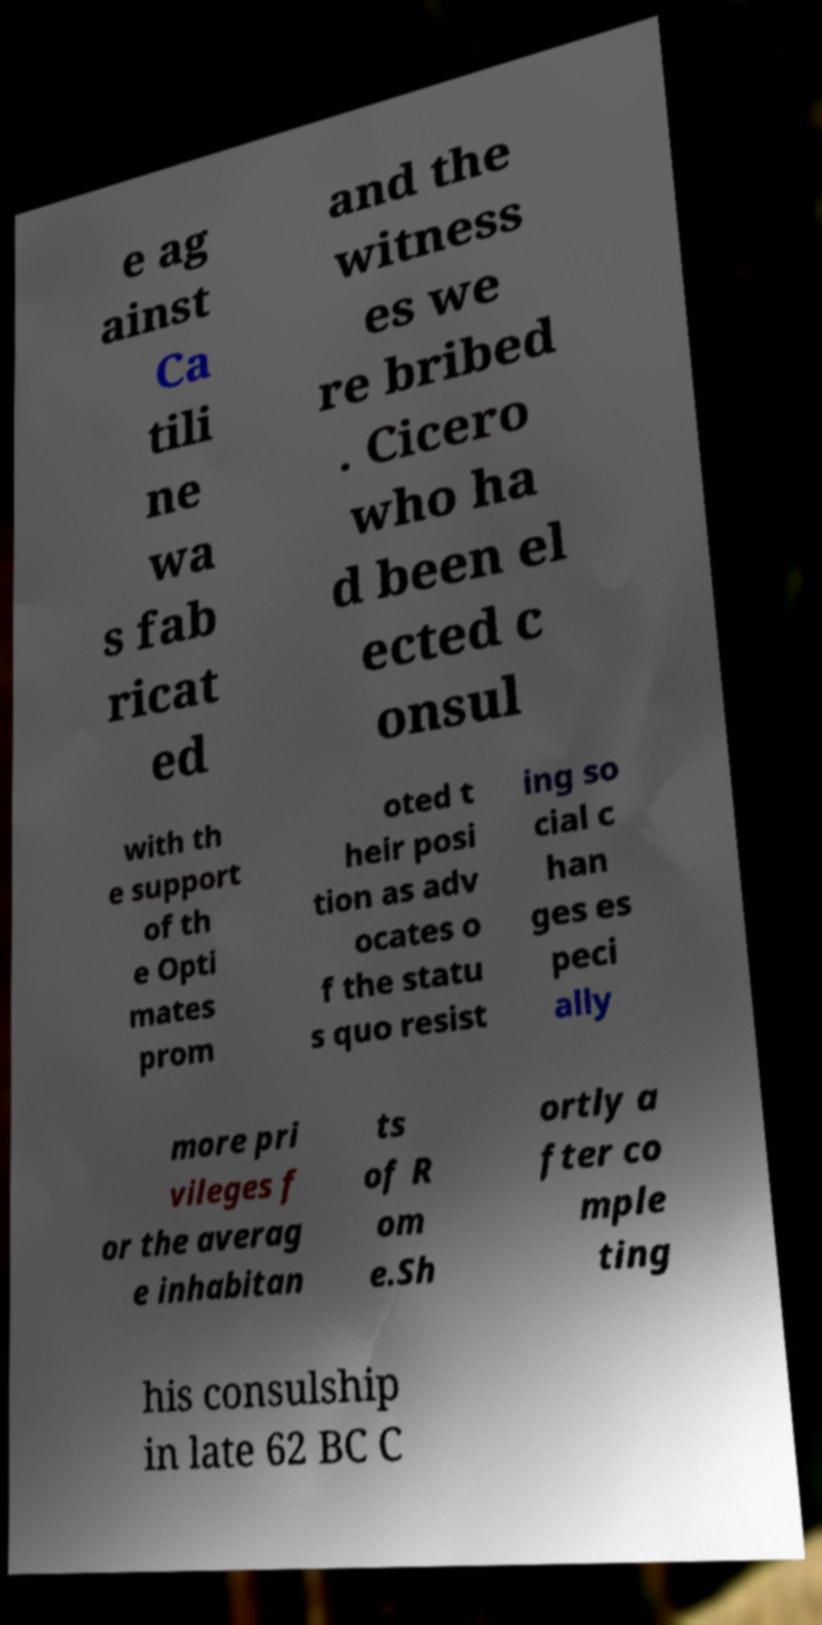Could you assist in decoding the text presented in this image and type it out clearly? e ag ainst Ca tili ne wa s fab ricat ed and the witness es we re bribed . Cicero who ha d been el ected c onsul with th e support of th e Opti mates prom oted t heir posi tion as adv ocates o f the statu s quo resist ing so cial c han ges es peci ally more pri vileges f or the averag e inhabitan ts of R om e.Sh ortly a fter co mple ting his consulship in late 62 BC C 